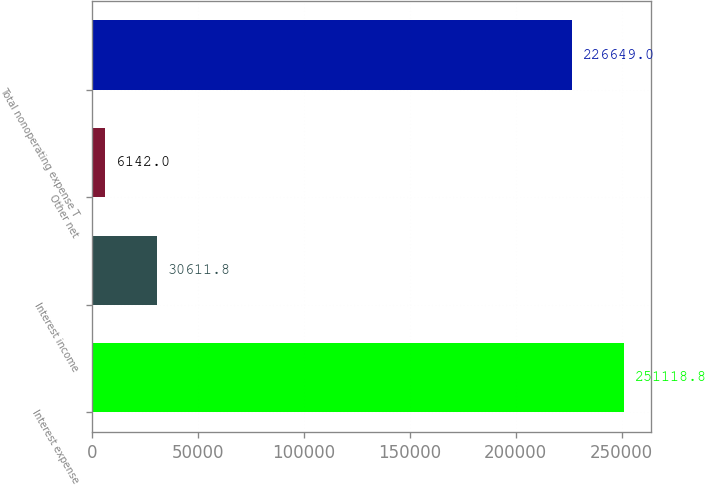<chart> <loc_0><loc_0><loc_500><loc_500><bar_chart><fcel>Interest expense<fcel>Interest income<fcel>Other net<fcel>Total nonoperating expense T<nl><fcel>251119<fcel>30611.8<fcel>6142<fcel>226649<nl></chart> 